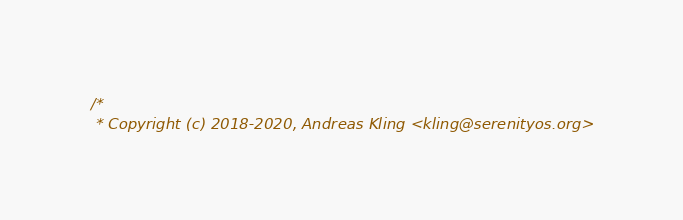Convert code to text. <code><loc_0><loc_0><loc_500><loc_500><_C_>/*
 * Copyright (c) 2018-2020, Andreas Kling <kling@serenityos.org></code> 